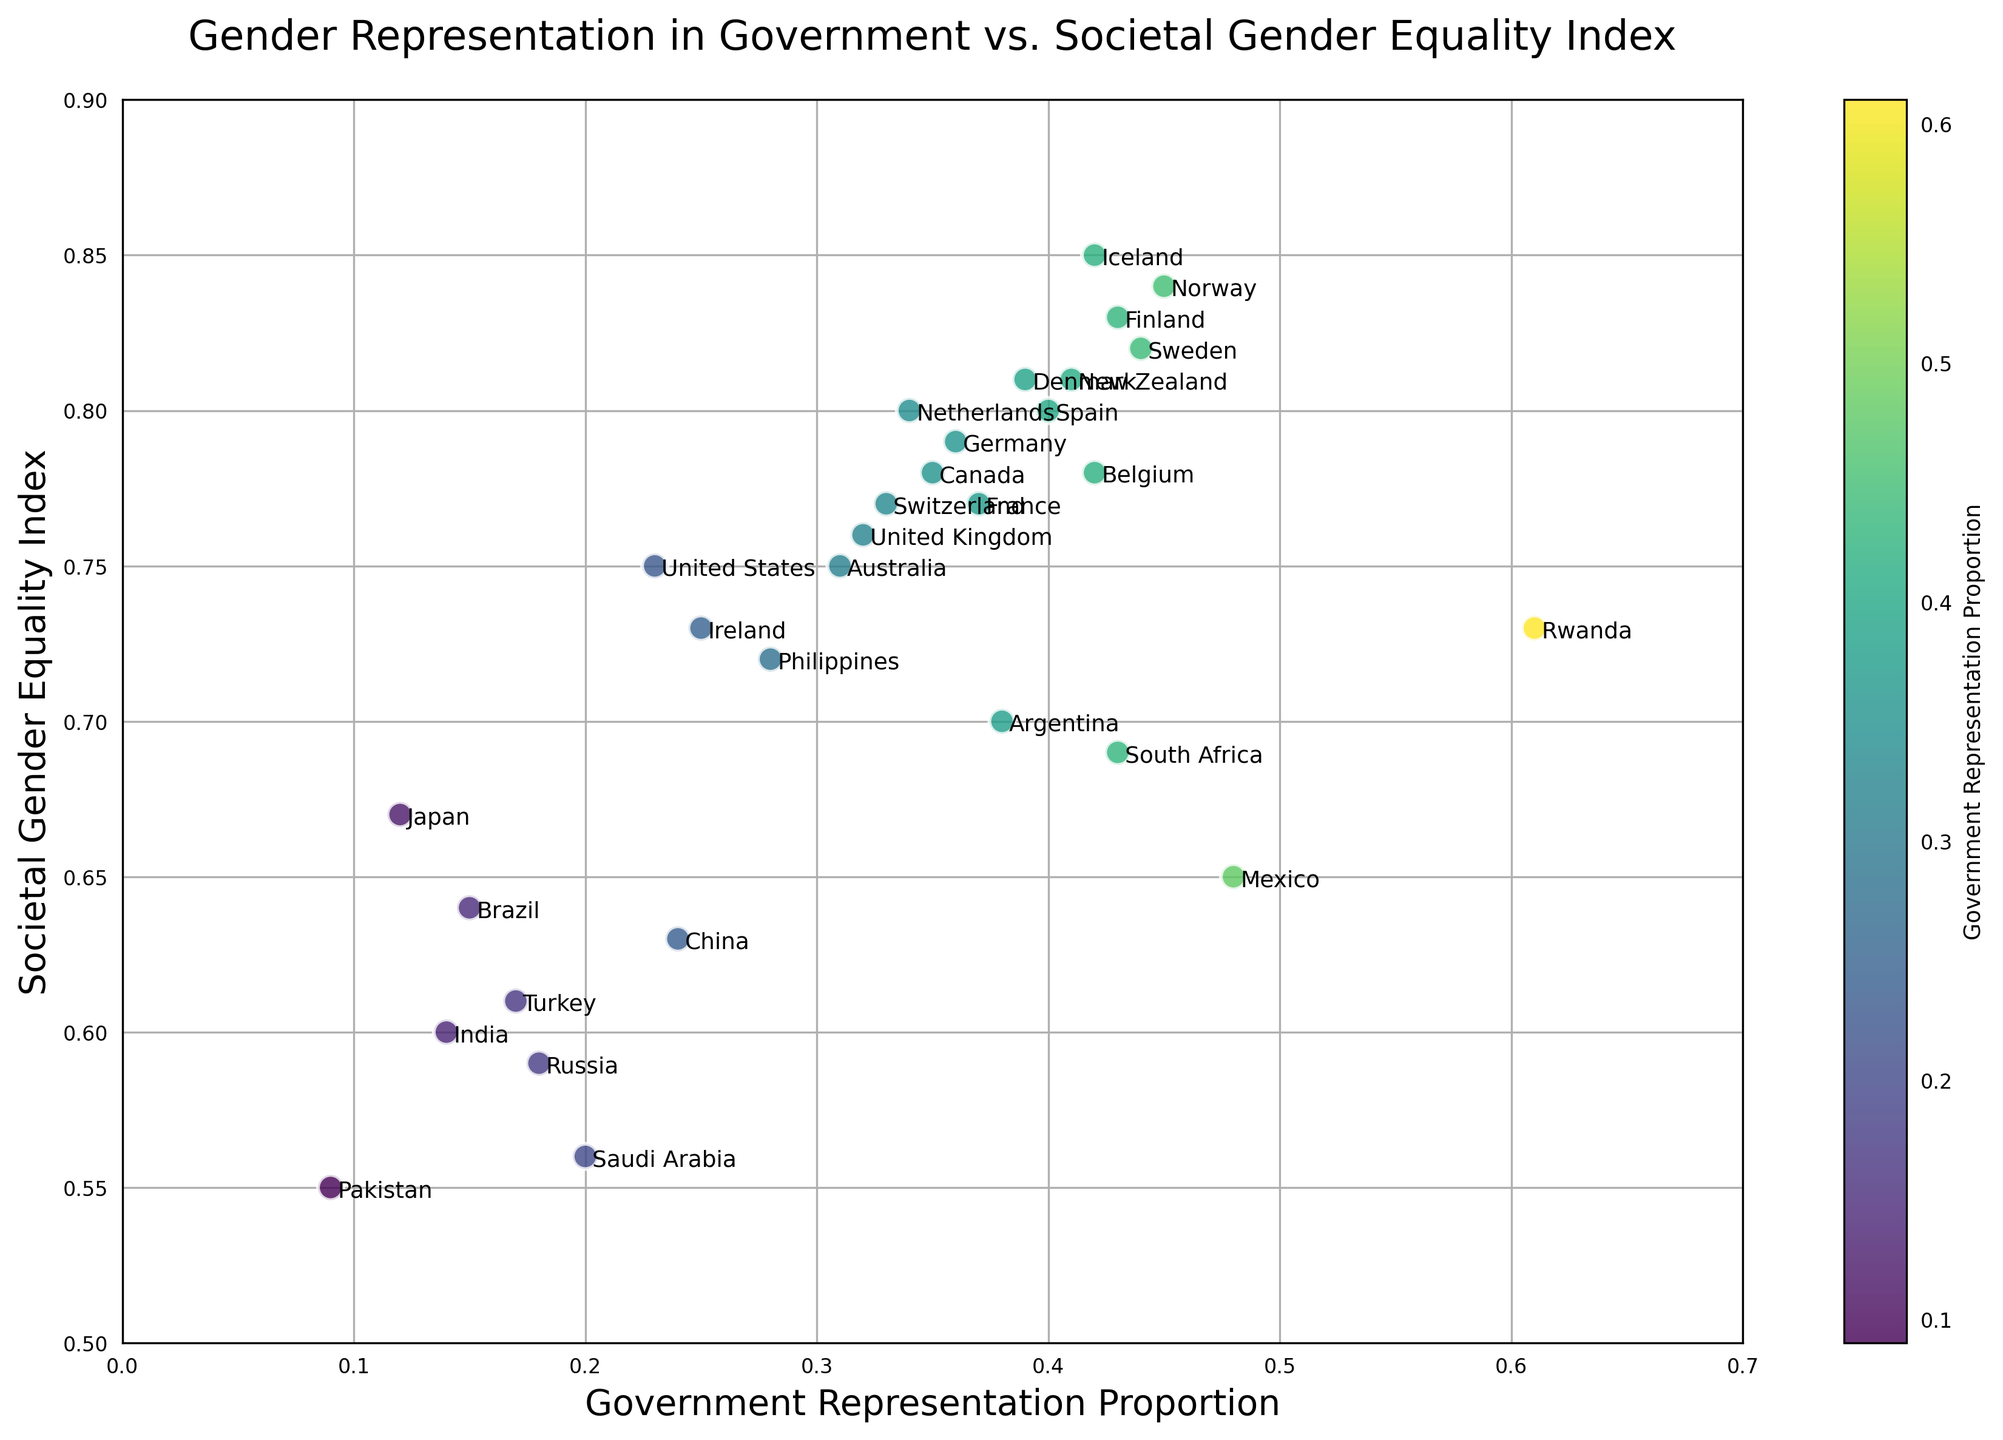Which country has the highest proportion of government representation? Look at the scatter plot to identify the point furthest to the right, which corresponds to the highest government representation. In this plot, Rwanda is the furthest right with a proportion of 0.61.
Answer: Rwanda How does the societal gender equality index for Norway compare to that for the United States? Locate the points corresponding to Norway and the United States on the scatter plot. Norway has an index of 0.84, while the United States has an index of 0.75. Thus, Norway has a higher societal gender equality index.
Answer: Norway has a higher index Which country has a higher government representation: Mexico or Argentina? Identify the points representing Mexico and Argentina and compare their positions on the x-axis. Mexico is at 0.48, while Argentina is at 0.38. Therefore, Mexico has higher government representation.
Answer: Mexico What is the general trend between government representation and societal gender equality index? Observe the scatter plot's distribution of points. A positive relationship is indicated where higher government representation correlates with a higher societal gender equality index.
Answer: Positive correlation How many countries have a societal gender equality index below 0.60? Count the points on the scatter plot that lie below the 0.60 mark on the y-axis. These countries are India, Saudi Arabia, Russia, Turkey, Pakistan, and China, totaling 6.
Answer: 6 Which region has a better societal gender equality index, Northern Europe (e.g., Norway, Sweden, Finland) or South Asia (e.g., India, Pakistan)? Compare the y-axis values for countries in Northern Europe and South Asia. Northern European countries are clustered around 0.80-0.85, while South Asian countries (India, Pakistan) have values around 0.55-0.60.
Answer: Northern Europe Is there any country with a high government representation but relatively low societal gender equality index? Look for a point far to the right on the x-axis but lower on the y-axis. Rwanda (0.61, 0.73) stands out as having high representation but a relatively lower equality index compared to other countries with similar representation.
Answer: Rwanda Which country among Canada, Australia, and Brazil has the least societal gender equality index? Locate the points for Canada (0.78), Australia (0.75), and Brazil (0.64) and compare the y-axis values. Brazil has the lowest value among these three.
Answer: Brazil What is the difference in government representation proportions between the country with the highest proportion and the country with the lowest? The highest is Rwanda at 0.61, and the lowest is Pakistan at 0.09. The difference is calculated as 0.61 - 0.09 = 0.52.
Answer: 0.52 Which countries have a government representation proportion between 0.30 and 0.40? Identify the points on the scatter plot whose x-values fall between 0.30 and 0.40. These include Germany (0.36), Canada (0.35), France (0.37), Netherlands (0.34), United Kingdom (0.32), and Australia (0.31).
Answer: Germany, Canada, France, Netherlands, United Kingdom, Australia 